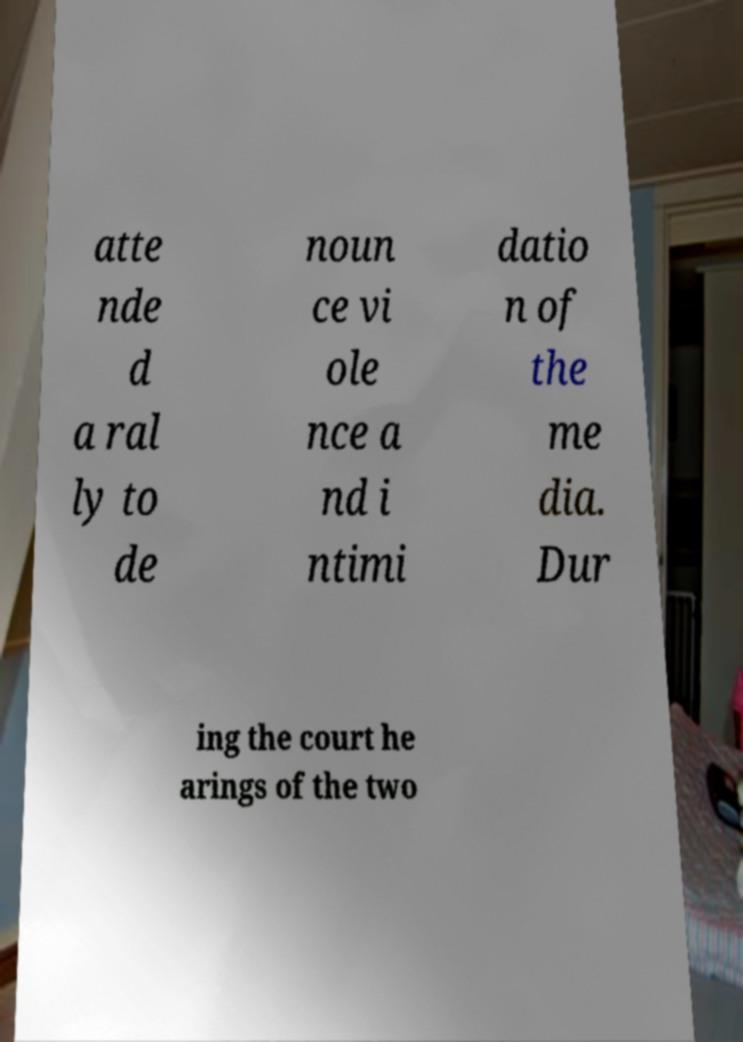I need the written content from this picture converted into text. Can you do that? atte nde d a ral ly to de noun ce vi ole nce a nd i ntimi datio n of the me dia. Dur ing the court he arings of the two 